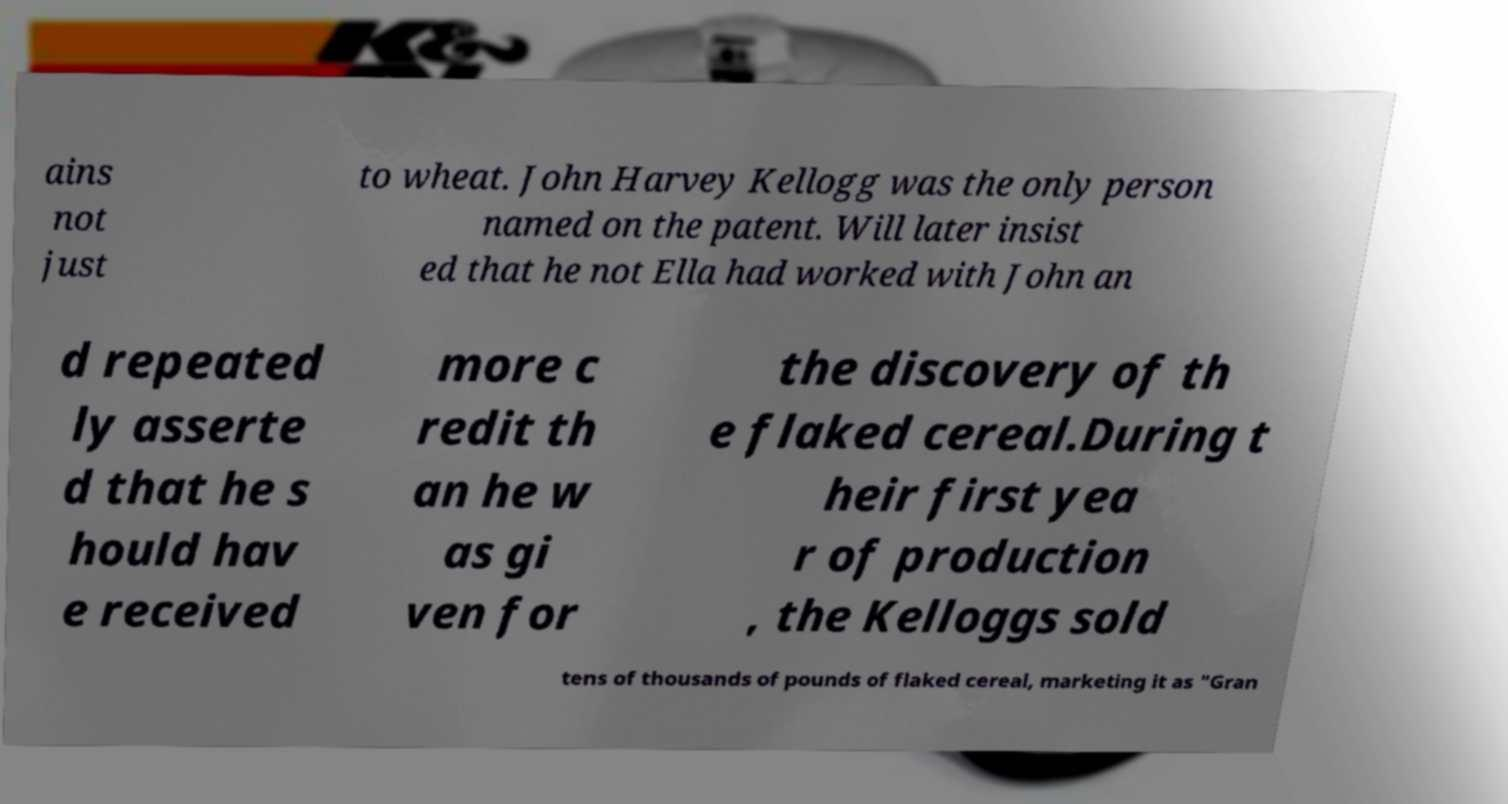Could you extract and type out the text from this image? ains not just to wheat. John Harvey Kellogg was the only person named on the patent. Will later insist ed that he not Ella had worked with John an d repeated ly asserte d that he s hould hav e received more c redit th an he w as gi ven for the discovery of th e flaked cereal.During t heir first yea r of production , the Kelloggs sold tens of thousands of pounds of flaked cereal, marketing it as "Gran 